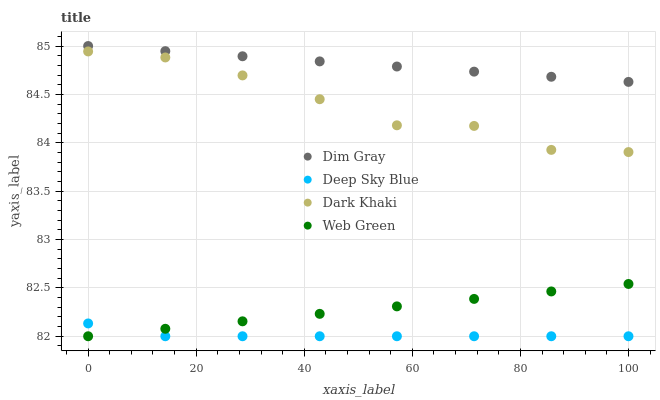Does Deep Sky Blue have the minimum area under the curve?
Answer yes or no. Yes. Does Dim Gray have the maximum area under the curve?
Answer yes or no. Yes. Does Web Green have the minimum area under the curve?
Answer yes or no. No. Does Web Green have the maximum area under the curve?
Answer yes or no. No. Is Web Green the smoothest?
Answer yes or no. Yes. Is Dark Khaki the roughest?
Answer yes or no. Yes. Is Dim Gray the smoothest?
Answer yes or no. No. Is Dim Gray the roughest?
Answer yes or no. No. Does Web Green have the lowest value?
Answer yes or no. Yes. Does Dim Gray have the lowest value?
Answer yes or no. No. Does Dim Gray have the highest value?
Answer yes or no. Yes. Does Web Green have the highest value?
Answer yes or no. No. Is Web Green less than Dim Gray?
Answer yes or no. Yes. Is Dark Khaki greater than Deep Sky Blue?
Answer yes or no. Yes. Does Web Green intersect Deep Sky Blue?
Answer yes or no. Yes. Is Web Green less than Deep Sky Blue?
Answer yes or no. No. Is Web Green greater than Deep Sky Blue?
Answer yes or no. No. Does Web Green intersect Dim Gray?
Answer yes or no. No. 